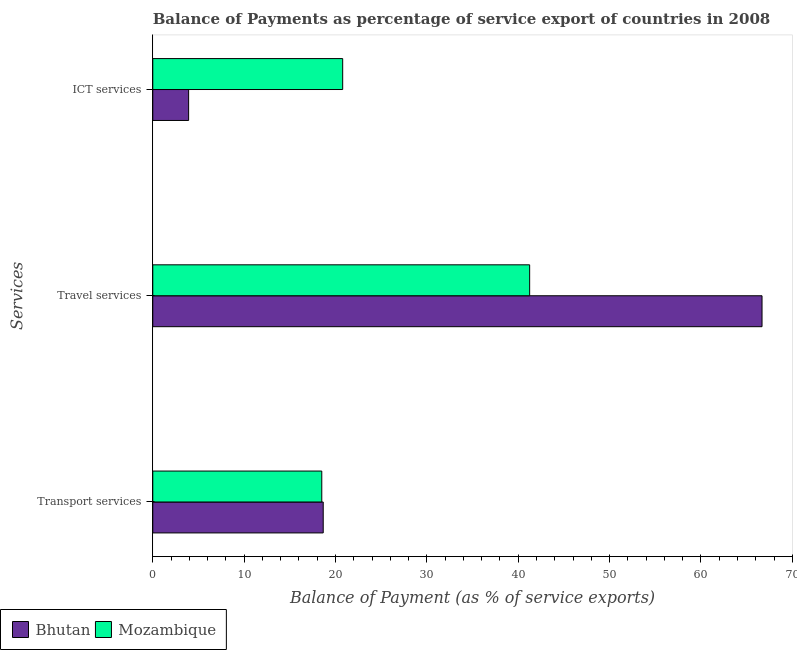Are the number of bars on each tick of the Y-axis equal?
Offer a terse response. Yes. How many bars are there on the 1st tick from the top?
Provide a succinct answer. 2. What is the label of the 2nd group of bars from the top?
Your answer should be very brief. Travel services. What is the balance of payment of ict services in Bhutan?
Provide a succinct answer. 3.92. Across all countries, what is the maximum balance of payment of ict services?
Make the answer very short. 20.79. Across all countries, what is the minimum balance of payment of travel services?
Give a very brief answer. 41.25. In which country was the balance of payment of transport services maximum?
Offer a terse response. Bhutan. In which country was the balance of payment of transport services minimum?
Make the answer very short. Mozambique. What is the total balance of payment of travel services in the graph?
Ensure brevity in your answer.  107.93. What is the difference between the balance of payment of ict services in Mozambique and that in Bhutan?
Provide a short and direct response. 16.86. What is the difference between the balance of payment of ict services in Bhutan and the balance of payment of travel services in Mozambique?
Your answer should be very brief. -37.33. What is the average balance of payment of ict services per country?
Offer a terse response. 12.36. What is the difference between the balance of payment of transport services and balance of payment of travel services in Mozambique?
Ensure brevity in your answer.  -22.75. In how many countries, is the balance of payment of travel services greater than 26 %?
Your response must be concise. 2. What is the ratio of the balance of payment of travel services in Mozambique to that in Bhutan?
Offer a very short reply. 0.62. Is the balance of payment of ict services in Bhutan less than that in Mozambique?
Your answer should be compact. Yes. What is the difference between the highest and the second highest balance of payment of transport services?
Ensure brevity in your answer.  0.16. What is the difference between the highest and the lowest balance of payment of travel services?
Provide a short and direct response. 25.43. In how many countries, is the balance of payment of transport services greater than the average balance of payment of transport services taken over all countries?
Give a very brief answer. 1. Is the sum of the balance of payment of transport services in Mozambique and Bhutan greater than the maximum balance of payment of travel services across all countries?
Your answer should be compact. No. What does the 1st bar from the top in Transport services represents?
Offer a terse response. Mozambique. What does the 1st bar from the bottom in Transport services represents?
Your response must be concise. Bhutan. How many bars are there?
Provide a succinct answer. 6. How many countries are there in the graph?
Keep it short and to the point. 2. Are the values on the major ticks of X-axis written in scientific E-notation?
Provide a short and direct response. No. Does the graph contain any zero values?
Your response must be concise. No. What is the title of the graph?
Give a very brief answer. Balance of Payments as percentage of service export of countries in 2008. Does "Zambia" appear as one of the legend labels in the graph?
Provide a succinct answer. No. What is the label or title of the X-axis?
Offer a terse response. Balance of Payment (as % of service exports). What is the label or title of the Y-axis?
Your answer should be very brief. Services. What is the Balance of Payment (as % of service exports) of Bhutan in Transport services?
Provide a short and direct response. 18.65. What is the Balance of Payment (as % of service exports) of Mozambique in Transport services?
Make the answer very short. 18.5. What is the Balance of Payment (as % of service exports) of Bhutan in Travel services?
Offer a very short reply. 66.68. What is the Balance of Payment (as % of service exports) in Mozambique in Travel services?
Provide a succinct answer. 41.25. What is the Balance of Payment (as % of service exports) of Bhutan in ICT services?
Give a very brief answer. 3.92. What is the Balance of Payment (as % of service exports) in Mozambique in ICT services?
Your response must be concise. 20.79. Across all Services, what is the maximum Balance of Payment (as % of service exports) of Bhutan?
Ensure brevity in your answer.  66.68. Across all Services, what is the maximum Balance of Payment (as % of service exports) of Mozambique?
Keep it short and to the point. 41.25. Across all Services, what is the minimum Balance of Payment (as % of service exports) in Bhutan?
Provide a short and direct response. 3.92. Across all Services, what is the minimum Balance of Payment (as % of service exports) in Mozambique?
Your answer should be compact. 18.5. What is the total Balance of Payment (as % of service exports) of Bhutan in the graph?
Provide a short and direct response. 89.26. What is the total Balance of Payment (as % of service exports) in Mozambique in the graph?
Offer a very short reply. 80.54. What is the difference between the Balance of Payment (as % of service exports) of Bhutan in Transport services and that in Travel services?
Your response must be concise. -48.03. What is the difference between the Balance of Payment (as % of service exports) in Mozambique in Transport services and that in Travel services?
Your answer should be compact. -22.75. What is the difference between the Balance of Payment (as % of service exports) of Bhutan in Transport services and that in ICT services?
Your answer should be very brief. 14.73. What is the difference between the Balance of Payment (as % of service exports) of Mozambique in Transport services and that in ICT services?
Provide a short and direct response. -2.29. What is the difference between the Balance of Payment (as % of service exports) of Bhutan in Travel services and that in ICT services?
Give a very brief answer. 62.76. What is the difference between the Balance of Payment (as % of service exports) in Mozambique in Travel services and that in ICT services?
Ensure brevity in your answer.  20.46. What is the difference between the Balance of Payment (as % of service exports) of Bhutan in Transport services and the Balance of Payment (as % of service exports) of Mozambique in Travel services?
Keep it short and to the point. -22.6. What is the difference between the Balance of Payment (as % of service exports) in Bhutan in Transport services and the Balance of Payment (as % of service exports) in Mozambique in ICT services?
Provide a succinct answer. -2.13. What is the difference between the Balance of Payment (as % of service exports) of Bhutan in Travel services and the Balance of Payment (as % of service exports) of Mozambique in ICT services?
Offer a terse response. 45.9. What is the average Balance of Payment (as % of service exports) of Bhutan per Services?
Offer a terse response. 29.75. What is the average Balance of Payment (as % of service exports) in Mozambique per Services?
Make the answer very short. 26.85. What is the difference between the Balance of Payment (as % of service exports) of Bhutan and Balance of Payment (as % of service exports) of Mozambique in Transport services?
Offer a terse response. 0.16. What is the difference between the Balance of Payment (as % of service exports) in Bhutan and Balance of Payment (as % of service exports) in Mozambique in Travel services?
Your response must be concise. 25.43. What is the difference between the Balance of Payment (as % of service exports) of Bhutan and Balance of Payment (as % of service exports) of Mozambique in ICT services?
Provide a succinct answer. -16.86. What is the ratio of the Balance of Payment (as % of service exports) in Bhutan in Transport services to that in Travel services?
Make the answer very short. 0.28. What is the ratio of the Balance of Payment (as % of service exports) of Mozambique in Transport services to that in Travel services?
Your answer should be very brief. 0.45. What is the ratio of the Balance of Payment (as % of service exports) in Bhutan in Transport services to that in ICT services?
Provide a succinct answer. 4.75. What is the ratio of the Balance of Payment (as % of service exports) of Mozambique in Transport services to that in ICT services?
Your answer should be compact. 0.89. What is the ratio of the Balance of Payment (as % of service exports) of Bhutan in Travel services to that in ICT services?
Give a very brief answer. 16.99. What is the ratio of the Balance of Payment (as % of service exports) of Mozambique in Travel services to that in ICT services?
Ensure brevity in your answer.  1.98. What is the difference between the highest and the second highest Balance of Payment (as % of service exports) in Bhutan?
Provide a succinct answer. 48.03. What is the difference between the highest and the second highest Balance of Payment (as % of service exports) in Mozambique?
Offer a very short reply. 20.46. What is the difference between the highest and the lowest Balance of Payment (as % of service exports) of Bhutan?
Keep it short and to the point. 62.76. What is the difference between the highest and the lowest Balance of Payment (as % of service exports) of Mozambique?
Ensure brevity in your answer.  22.75. 